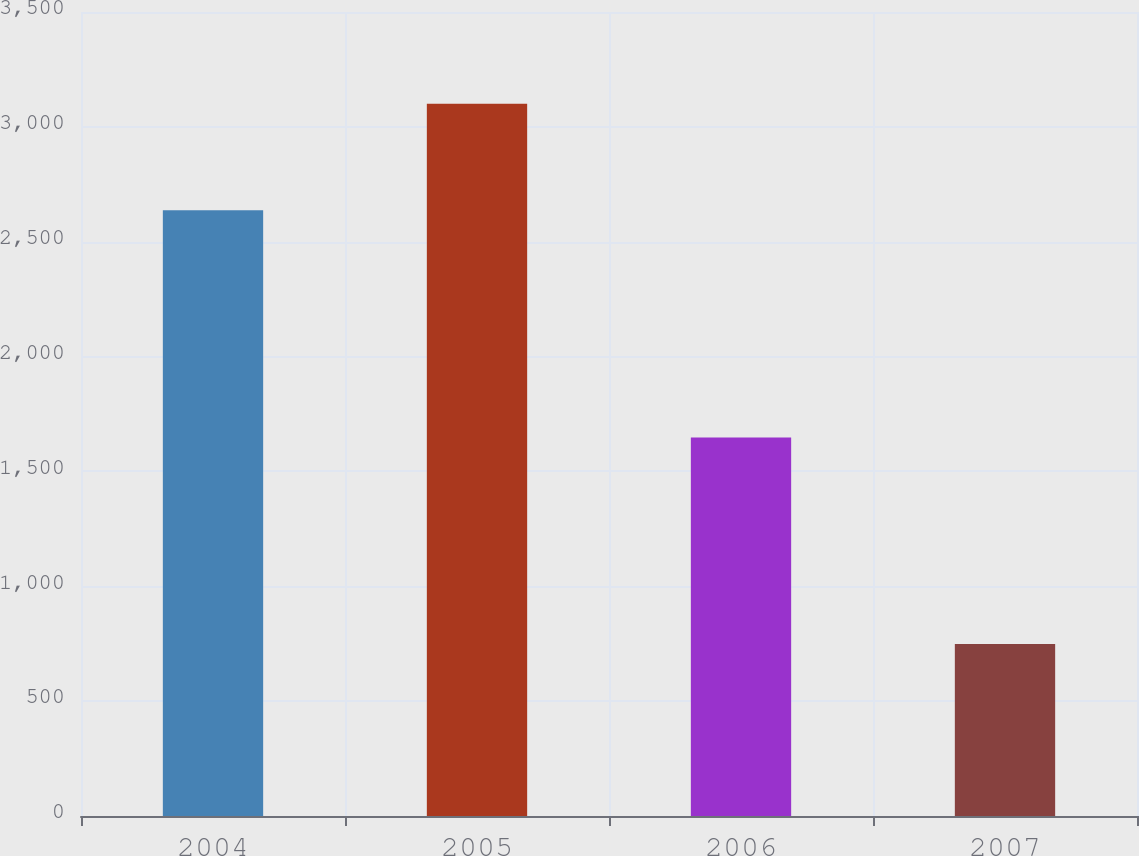Convert chart to OTSL. <chart><loc_0><loc_0><loc_500><loc_500><bar_chart><fcel>2004<fcel>2005<fcel>2006<fcel>2007<nl><fcel>2637<fcel>3101<fcel>1648<fcel>749<nl></chart> 